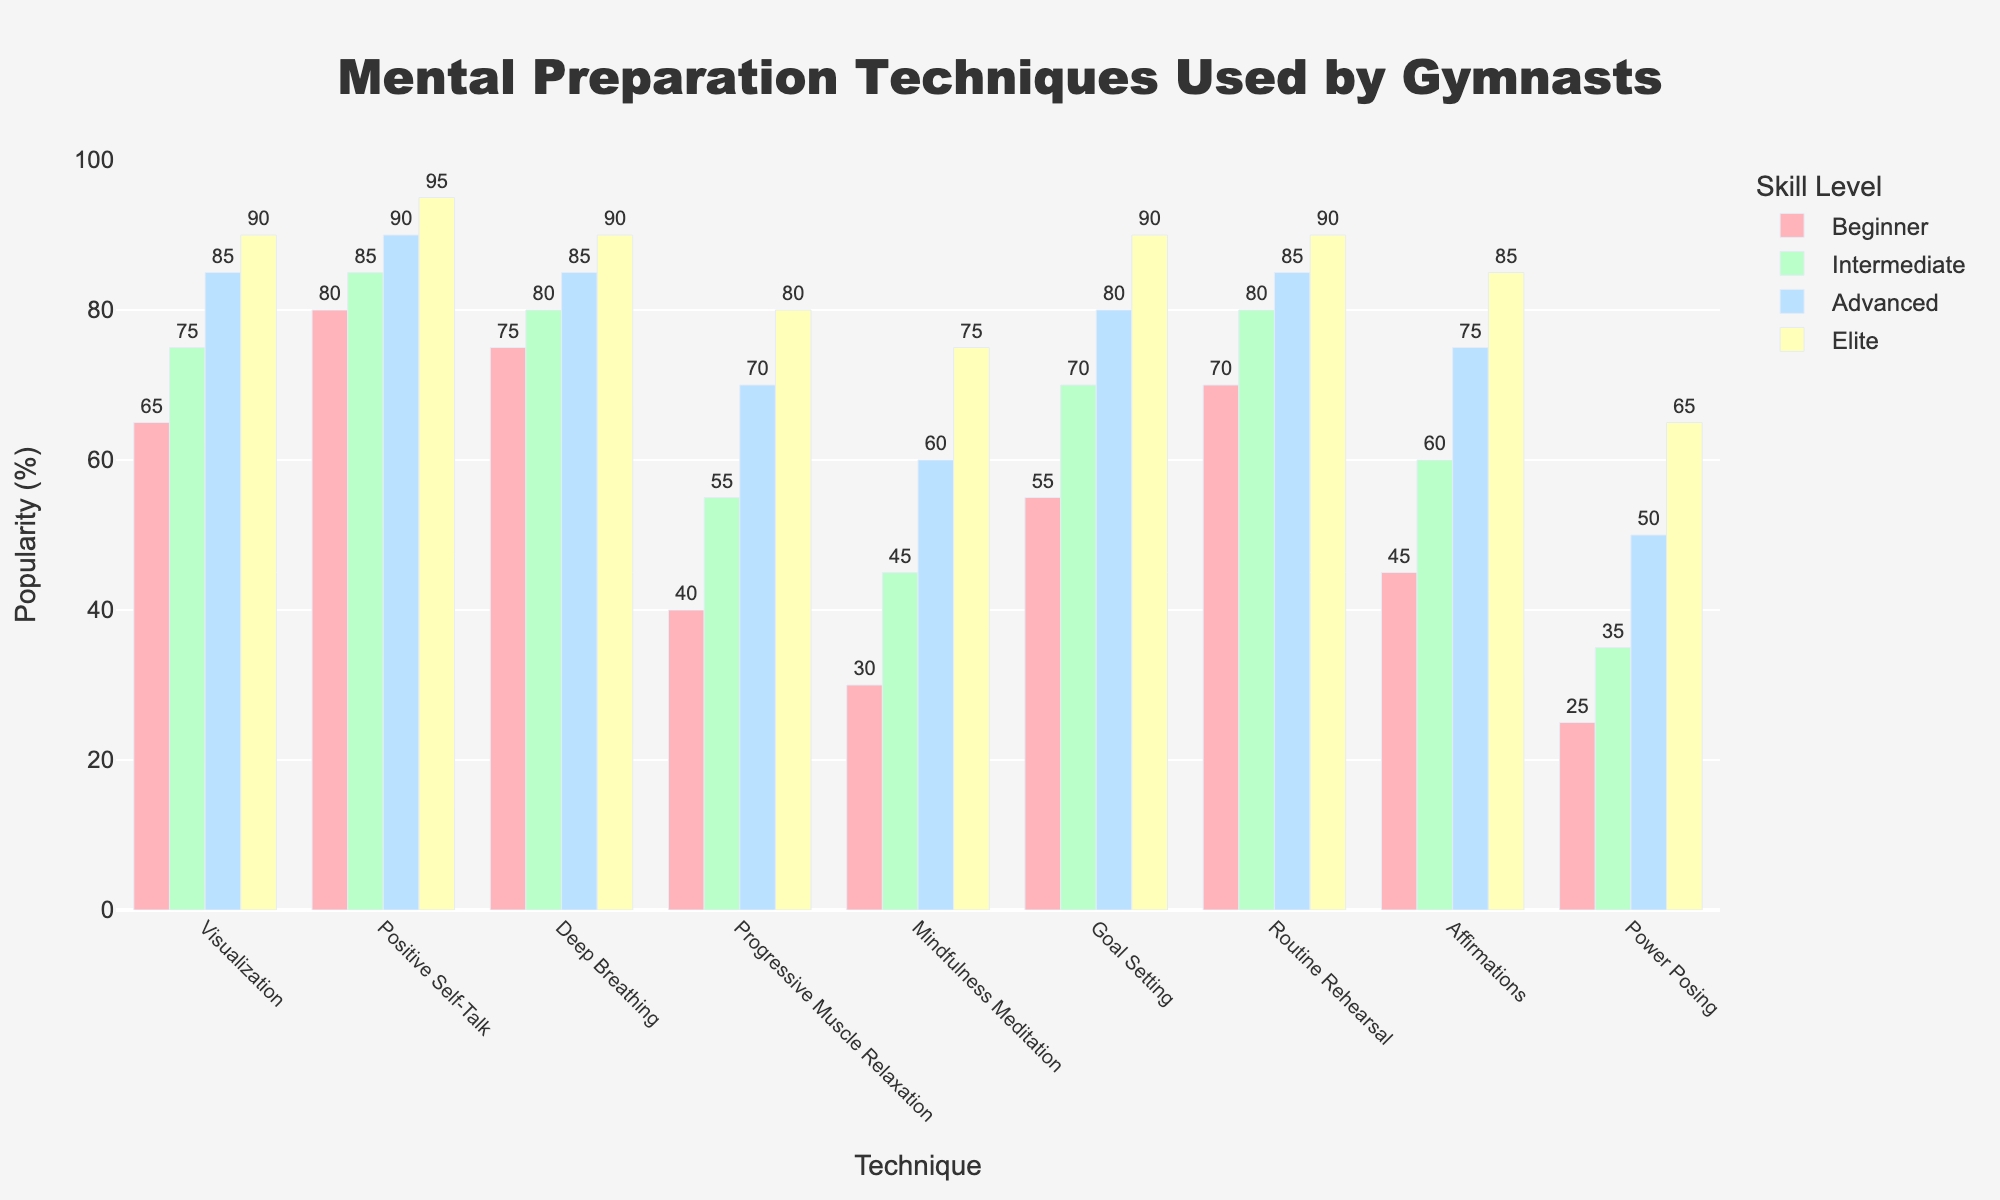Which skill level makes the most use of Positive Self-Talk? The bar corresponding to Positive Self-Talk is the tallest for the Elite skill level, reaching 95%.
Answer: Elite Which mental preparation technique is least used by Beginners? The shortest bar for Beginners corresponds to Power Posing, with a value of 25%.
Answer: Power Posing How much more popular is Deep Breathing among Elite gymnasts compared to Beginners? The value for Deep Breathing is 90% for Elite and 75% for Beginners. The difference is 90 - 75 = 15%.
Answer: 15% Among Advanced gymnasts, how do the popularity values of Affirmations and Routine Rehearsal compare? The bar for Affirmations among Advanced gymnasts is 75%, and for Routine Rehearsal, it is 85%. Thus, Routine Rehearsal is more popular by 85 - 75 = 10%.
Answer: Routine Rehearsal is 10% more popular What is the sum of popularity percentages for Visualization and Goal Setting techniques among Intermediate gymnasts? The values for Visualization and Goal Setting among Intermediate gymnasts are 75% and 70%, respectively. The sum is 75 + 70 = 145%.
Answer: 145% Which technique has a consistent upward trend in popularity across all skill levels? By observation, Positive Self-Talk shows a steady increase: 80% (Beginner), 85% (Intermediate), 90% (Advanced), and 95% (Elite).
Answer: Positive Self-Talk Which skill level uses Progressive Muscle Relaxation the least and how much is it? The bar for Progressive Muscle Relaxation is shortest for Beginners at 40%.
Answer: Beginner, 40% How does the popularity of Mindfulness Meditation for Intermediate gymnasts compare to Advanced gymnasts? Mindfulness Meditation is used 45% by Intermediate gymnasts and 60% by Advanced gymnasts. The difference is 60 - 45 = 15%.
Answer: 15% more for Advanced 